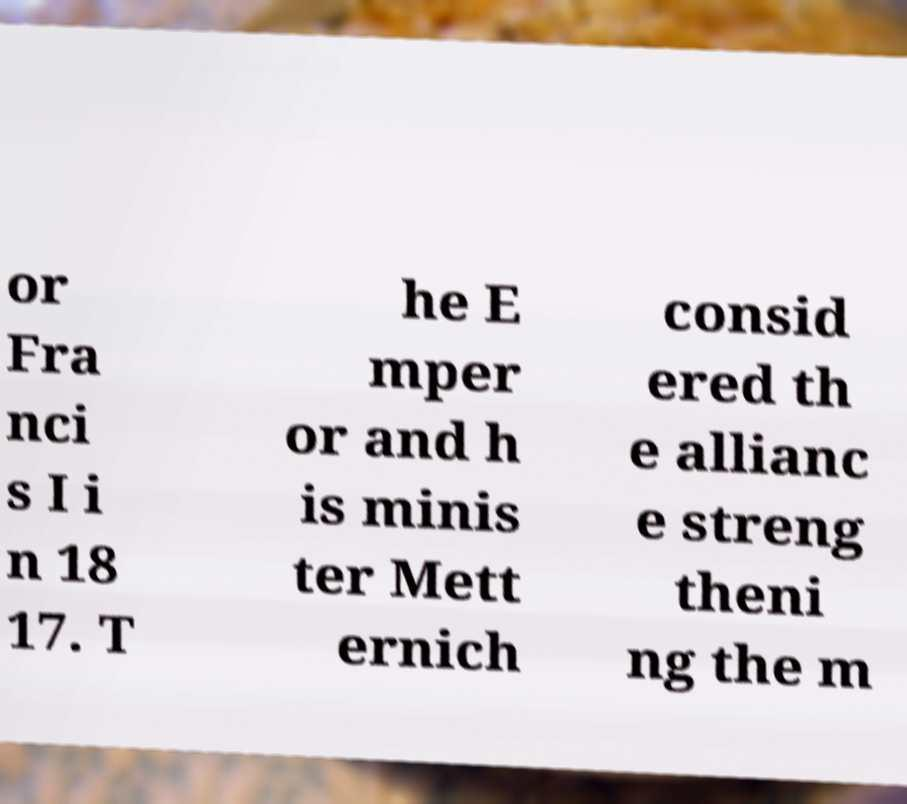Please identify and transcribe the text found in this image. or Fra nci s I i n 18 17. T he E mper or and h is minis ter Mett ernich consid ered th e allianc e streng theni ng the m 